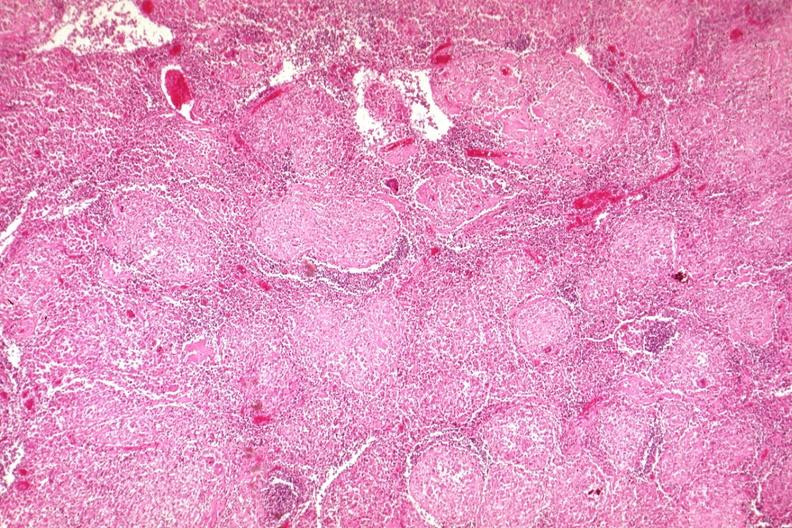s squamous cell carcinoma, lip remote, present?
Answer the question using a single word or phrase. No 